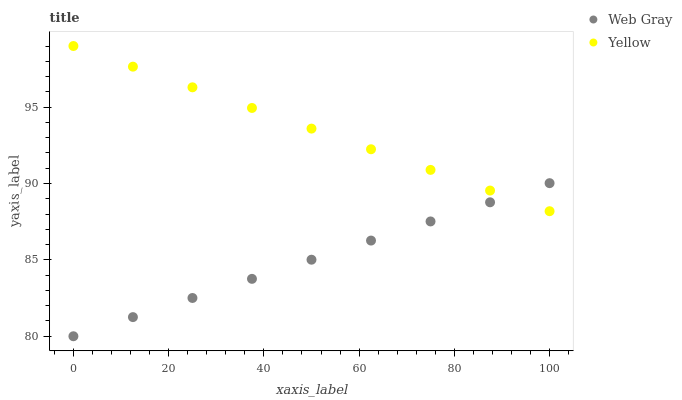Does Web Gray have the minimum area under the curve?
Answer yes or no. Yes. Does Yellow have the maximum area under the curve?
Answer yes or no. Yes. Does Yellow have the minimum area under the curve?
Answer yes or no. No. Is Web Gray the smoothest?
Answer yes or no. Yes. Is Yellow the roughest?
Answer yes or no. Yes. Is Yellow the smoothest?
Answer yes or no. No. Does Web Gray have the lowest value?
Answer yes or no. Yes. Does Yellow have the lowest value?
Answer yes or no. No. Does Yellow have the highest value?
Answer yes or no. Yes. Does Yellow intersect Web Gray?
Answer yes or no. Yes. Is Yellow less than Web Gray?
Answer yes or no. No. Is Yellow greater than Web Gray?
Answer yes or no. No. 